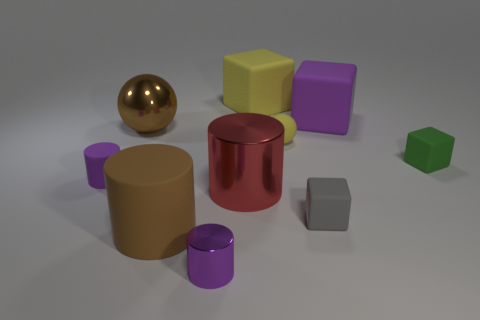There is a matte cube that is the same color as the tiny matte cylinder; what is its size?
Your answer should be very brief. Large. There is a large brown object that is to the left of the big rubber cylinder; is its shape the same as the small yellow rubber thing?
Offer a very short reply. Yes. What number of green cubes have the same size as the rubber ball?
Provide a short and direct response. 1. There is a large matte object that is the same color as the rubber sphere; what is its shape?
Offer a very short reply. Cube. Are there any gray rubber blocks that are behind the matte block in front of the small purple rubber thing?
Ensure brevity in your answer.  No. How many things are either brown things that are in front of the big brown sphere or large green rubber balls?
Keep it short and to the point. 1. How many brown rubber objects are there?
Keep it short and to the point. 1. The tiny purple thing that is the same material as the large brown sphere is what shape?
Give a very brief answer. Cylinder. What size is the rubber cube that is left of the yellow rubber ball that is behind the brown cylinder?
Provide a short and direct response. Large. How many objects are tiny objects that are right of the large brown ball or big matte cubes that are on the left side of the big purple object?
Offer a terse response. 5. 